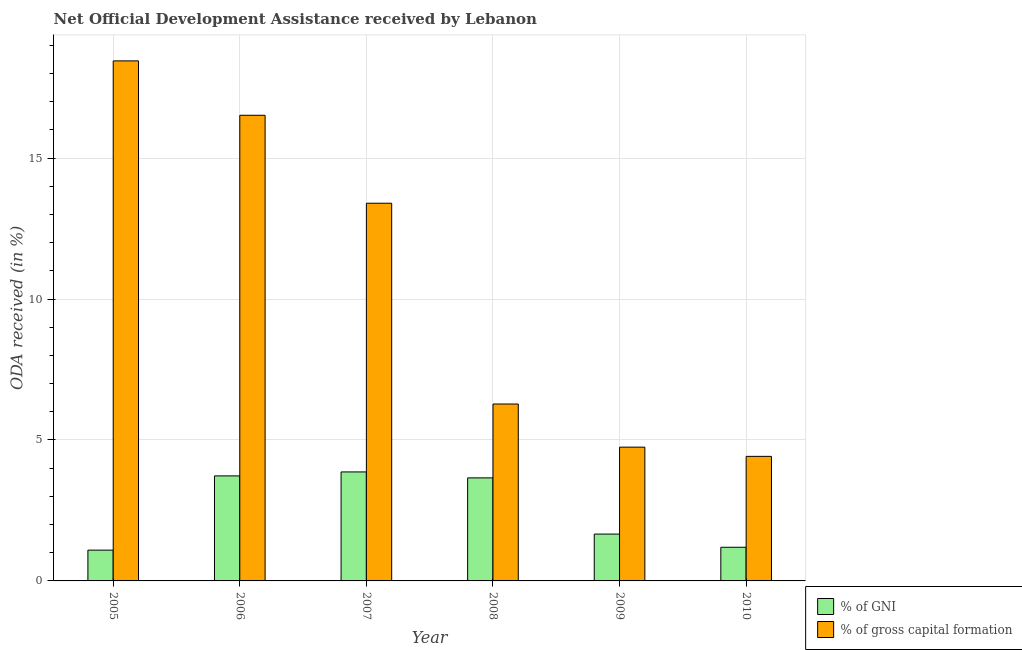How many different coloured bars are there?
Keep it short and to the point. 2. Are the number of bars on each tick of the X-axis equal?
Your answer should be compact. Yes. How many bars are there on the 1st tick from the left?
Your answer should be very brief. 2. How many bars are there on the 2nd tick from the right?
Provide a short and direct response. 2. What is the label of the 1st group of bars from the left?
Your answer should be compact. 2005. What is the oda received as percentage of gross capital formation in 2008?
Provide a short and direct response. 6.28. Across all years, what is the maximum oda received as percentage of gross capital formation?
Your answer should be very brief. 18.45. Across all years, what is the minimum oda received as percentage of gni?
Your response must be concise. 1.09. In which year was the oda received as percentage of gni maximum?
Offer a very short reply. 2007. What is the total oda received as percentage of gross capital formation in the graph?
Your answer should be very brief. 63.81. What is the difference between the oda received as percentage of gross capital formation in 2009 and that in 2010?
Your answer should be very brief. 0.33. What is the difference between the oda received as percentage of gni in 2005 and the oda received as percentage of gross capital formation in 2006?
Give a very brief answer. -2.63. What is the average oda received as percentage of gni per year?
Offer a terse response. 2.53. What is the ratio of the oda received as percentage of gross capital formation in 2006 to that in 2007?
Make the answer very short. 1.23. Is the oda received as percentage of gross capital formation in 2005 less than that in 2006?
Make the answer very short. No. What is the difference between the highest and the second highest oda received as percentage of gross capital formation?
Ensure brevity in your answer.  1.93. What is the difference between the highest and the lowest oda received as percentage of gni?
Provide a short and direct response. 2.77. In how many years, is the oda received as percentage of gross capital formation greater than the average oda received as percentage of gross capital formation taken over all years?
Your response must be concise. 3. What does the 2nd bar from the left in 2008 represents?
Provide a succinct answer. % of gross capital formation. What does the 1st bar from the right in 2007 represents?
Your answer should be very brief. % of gross capital formation. How many years are there in the graph?
Keep it short and to the point. 6. Does the graph contain any zero values?
Your answer should be very brief. No. How are the legend labels stacked?
Your answer should be compact. Vertical. What is the title of the graph?
Your answer should be very brief. Net Official Development Assistance received by Lebanon. What is the label or title of the Y-axis?
Provide a short and direct response. ODA received (in %). What is the ODA received (in %) of % of GNI in 2005?
Offer a very short reply. 1.09. What is the ODA received (in %) in % of gross capital formation in 2005?
Offer a terse response. 18.45. What is the ODA received (in %) of % of GNI in 2006?
Offer a very short reply. 3.73. What is the ODA received (in %) of % of gross capital formation in 2006?
Your response must be concise. 16.52. What is the ODA received (in %) of % of GNI in 2007?
Your answer should be very brief. 3.87. What is the ODA received (in %) in % of gross capital formation in 2007?
Keep it short and to the point. 13.4. What is the ODA received (in %) in % of GNI in 2008?
Your response must be concise. 3.66. What is the ODA received (in %) of % of gross capital formation in 2008?
Provide a short and direct response. 6.28. What is the ODA received (in %) in % of GNI in 2009?
Offer a terse response. 1.66. What is the ODA received (in %) in % of gross capital formation in 2009?
Ensure brevity in your answer.  4.75. What is the ODA received (in %) of % of GNI in 2010?
Make the answer very short. 1.19. What is the ODA received (in %) in % of gross capital formation in 2010?
Give a very brief answer. 4.42. Across all years, what is the maximum ODA received (in %) of % of GNI?
Ensure brevity in your answer.  3.87. Across all years, what is the maximum ODA received (in %) in % of gross capital formation?
Make the answer very short. 18.45. Across all years, what is the minimum ODA received (in %) in % of GNI?
Ensure brevity in your answer.  1.09. Across all years, what is the minimum ODA received (in %) of % of gross capital formation?
Provide a succinct answer. 4.42. What is the total ODA received (in %) in % of GNI in the graph?
Offer a very short reply. 15.2. What is the total ODA received (in %) of % of gross capital formation in the graph?
Keep it short and to the point. 63.81. What is the difference between the ODA received (in %) of % of GNI in 2005 and that in 2006?
Your answer should be very brief. -2.63. What is the difference between the ODA received (in %) of % of gross capital formation in 2005 and that in 2006?
Ensure brevity in your answer.  1.93. What is the difference between the ODA received (in %) in % of GNI in 2005 and that in 2007?
Your response must be concise. -2.77. What is the difference between the ODA received (in %) in % of gross capital formation in 2005 and that in 2007?
Make the answer very short. 5.05. What is the difference between the ODA received (in %) in % of GNI in 2005 and that in 2008?
Give a very brief answer. -2.56. What is the difference between the ODA received (in %) of % of gross capital formation in 2005 and that in 2008?
Provide a short and direct response. 12.17. What is the difference between the ODA received (in %) in % of GNI in 2005 and that in 2009?
Offer a terse response. -0.57. What is the difference between the ODA received (in %) in % of gross capital formation in 2005 and that in 2009?
Provide a short and direct response. 13.7. What is the difference between the ODA received (in %) of % of GNI in 2005 and that in 2010?
Make the answer very short. -0.1. What is the difference between the ODA received (in %) of % of gross capital formation in 2005 and that in 2010?
Give a very brief answer. 14.03. What is the difference between the ODA received (in %) of % of GNI in 2006 and that in 2007?
Make the answer very short. -0.14. What is the difference between the ODA received (in %) in % of gross capital formation in 2006 and that in 2007?
Offer a terse response. 3.12. What is the difference between the ODA received (in %) of % of GNI in 2006 and that in 2008?
Your answer should be compact. 0.07. What is the difference between the ODA received (in %) of % of gross capital formation in 2006 and that in 2008?
Provide a succinct answer. 10.24. What is the difference between the ODA received (in %) in % of GNI in 2006 and that in 2009?
Provide a succinct answer. 2.06. What is the difference between the ODA received (in %) in % of gross capital formation in 2006 and that in 2009?
Provide a short and direct response. 11.77. What is the difference between the ODA received (in %) in % of GNI in 2006 and that in 2010?
Provide a short and direct response. 2.53. What is the difference between the ODA received (in %) of % of gross capital formation in 2006 and that in 2010?
Your answer should be very brief. 12.1. What is the difference between the ODA received (in %) of % of GNI in 2007 and that in 2008?
Provide a short and direct response. 0.21. What is the difference between the ODA received (in %) in % of gross capital formation in 2007 and that in 2008?
Your answer should be compact. 7.12. What is the difference between the ODA received (in %) in % of GNI in 2007 and that in 2009?
Provide a short and direct response. 2.2. What is the difference between the ODA received (in %) in % of gross capital formation in 2007 and that in 2009?
Your response must be concise. 8.65. What is the difference between the ODA received (in %) of % of GNI in 2007 and that in 2010?
Make the answer very short. 2.67. What is the difference between the ODA received (in %) in % of gross capital formation in 2007 and that in 2010?
Your answer should be very brief. 8.98. What is the difference between the ODA received (in %) in % of GNI in 2008 and that in 2009?
Provide a succinct answer. 1.99. What is the difference between the ODA received (in %) in % of gross capital formation in 2008 and that in 2009?
Provide a succinct answer. 1.53. What is the difference between the ODA received (in %) of % of GNI in 2008 and that in 2010?
Make the answer very short. 2.46. What is the difference between the ODA received (in %) in % of gross capital formation in 2008 and that in 2010?
Offer a terse response. 1.86. What is the difference between the ODA received (in %) in % of GNI in 2009 and that in 2010?
Ensure brevity in your answer.  0.47. What is the difference between the ODA received (in %) of % of gross capital formation in 2009 and that in 2010?
Your response must be concise. 0.33. What is the difference between the ODA received (in %) of % of GNI in 2005 and the ODA received (in %) of % of gross capital formation in 2006?
Ensure brevity in your answer.  -15.43. What is the difference between the ODA received (in %) in % of GNI in 2005 and the ODA received (in %) in % of gross capital formation in 2007?
Your response must be concise. -12.31. What is the difference between the ODA received (in %) in % of GNI in 2005 and the ODA received (in %) in % of gross capital formation in 2008?
Make the answer very short. -5.18. What is the difference between the ODA received (in %) in % of GNI in 2005 and the ODA received (in %) in % of gross capital formation in 2009?
Make the answer very short. -3.65. What is the difference between the ODA received (in %) in % of GNI in 2005 and the ODA received (in %) in % of gross capital formation in 2010?
Make the answer very short. -3.33. What is the difference between the ODA received (in %) of % of GNI in 2006 and the ODA received (in %) of % of gross capital formation in 2007?
Provide a succinct answer. -9.67. What is the difference between the ODA received (in %) in % of GNI in 2006 and the ODA received (in %) in % of gross capital formation in 2008?
Offer a terse response. -2.55. What is the difference between the ODA received (in %) in % of GNI in 2006 and the ODA received (in %) in % of gross capital formation in 2009?
Provide a succinct answer. -1.02. What is the difference between the ODA received (in %) of % of GNI in 2006 and the ODA received (in %) of % of gross capital formation in 2010?
Ensure brevity in your answer.  -0.69. What is the difference between the ODA received (in %) of % of GNI in 2007 and the ODA received (in %) of % of gross capital formation in 2008?
Keep it short and to the point. -2.41. What is the difference between the ODA received (in %) in % of GNI in 2007 and the ODA received (in %) in % of gross capital formation in 2009?
Provide a short and direct response. -0.88. What is the difference between the ODA received (in %) of % of GNI in 2007 and the ODA received (in %) of % of gross capital formation in 2010?
Provide a short and direct response. -0.55. What is the difference between the ODA received (in %) of % of GNI in 2008 and the ODA received (in %) of % of gross capital formation in 2009?
Your answer should be compact. -1.09. What is the difference between the ODA received (in %) in % of GNI in 2008 and the ODA received (in %) in % of gross capital formation in 2010?
Your response must be concise. -0.76. What is the difference between the ODA received (in %) of % of GNI in 2009 and the ODA received (in %) of % of gross capital formation in 2010?
Your response must be concise. -2.76. What is the average ODA received (in %) of % of GNI per year?
Keep it short and to the point. 2.53. What is the average ODA received (in %) of % of gross capital formation per year?
Provide a short and direct response. 10.64. In the year 2005, what is the difference between the ODA received (in %) in % of GNI and ODA received (in %) in % of gross capital formation?
Keep it short and to the point. -17.36. In the year 2006, what is the difference between the ODA received (in %) of % of GNI and ODA received (in %) of % of gross capital formation?
Your answer should be compact. -12.79. In the year 2007, what is the difference between the ODA received (in %) in % of GNI and ODA received (in %) in % of gross capital formation?
Your response must be concise. -9.53. In the year 2008, what is the difference between the ODA received (in %) in % of GNI and ODA received (in %) in % of gross capital formation?
Your answer should be very brief. -2.62. In the year 2009, what is the difference between the ODA received (in %) in % of GNI and ODA received (in %) in % of gross capital formation?
Your answer should be very brief. -3.08. In the year 2010, what is the difference between the ODA received (in %) in % of GNI and ODA received (in %) in % of gross capital formation?
Give a very brief answer. -3.22. What is the ratio of the ODA received (in %) in % of GNI in 2005 to that in 2006?
Make the answer very short. 0.29. What is the ratio of the ODA received (in %) in % of gross capital formation in 2005 to that in 2006?
Provide a succinct answer. 1.12. What is the ratio of the ODA received (in %) of % of GNI in 2005 to that in 2007?
Keep it short and to the point. 0.28. What is the ratio of the ODA received (in %) in % of gross capital formation in 2005 to that in 2007?
Your response must be concise. 1.38. What is the ratio of the ODA received (in %) of % of GNI in 2005 to that in 2008?
Provide a short and direct response. 0.3. What is the ratio of the ODA received (in %) of % of gross capital formation in 2005 to that in 2008?
Provide a succinct answer. 2.94. What is the ratio of the ODA received (in %) of % of GNI in 2005 to that in 2009?
Ensure brevity in your answer.  0.66. What is the ratio of the ODA received (in %) in % of gross capital formation in 2005 to that in 2009?
Give a very brief answer. 3.89. What is the ratio of the ODA received (in %) of % of GNI in 2005 to that in 2010?
Your answer should be compact. 0.91. What is the ratio of the ODA received (in %) of % of gross capital formation in 2005 to that in 2010?
Offer a terse response. 4.18. What is the ratio of the ODA received (in %) in % of GNI in 2006 to that in 2007?
Offer a terse response. 0.96. What is the ratio of the ODA received (in %) of % of gross capital formation in 2006 to that in 2007?
Your response must be concise. 1.23. What is the ratio of the ODA received (in %) of % of GNI in 2006 to that in 2008?
Provide a succinct answer. 1.02. What is the ratio of the ODA received (in %) of % of gross capital formation in 2006 to that in 2008?
Make the answer very short. 2.63. What is the ratio of the ODA received (in %) in % of GNI in 2006 to that in 2009?
Your answer should be compact. 2.24. What is the ratio of the ODA received (in %) in % of gross capital formation in 2006 to that in 2009?
Your answer should be very brief. 3.48. What is the ratio of the ODA received (in %) in % of GNI in 2006 to that in 2010?
Provide a short and direct response. 3.12. What is the ratio of the ODA received (in %) of % of gross capital formation in 2006 to that in 2010?
Provide a short and direct response. 3.74. What is the ratio of the ODA received (in %) in % of GNI in 2007 to that in 2008?
Keep it short and to the point. 1.06. What is the ratio of the ODA received (in %) of % of gross capital formation in 2007 to that in 2008?
Your response must be concise. 2.13. What is the ratio of the ODA received (in %) of % of GNI in 2007 to that in 2009?
Offer a very short reply. 2.33. What is the ratio of the ODA received (in %) of % of gross capital formation in 2007 to that in 2009?
Make the answer very short. 2.82. What is the ratio of the ODA received (in %) of % of GNI in 2007 to that in 2010?
Your answer should be very brief. 3.24. What is the ratio of the ODA received (in %) of % of gross capital formation in 2007 to that in 2010?
Provide a short and direct response. 3.03. What is the ratio of the ODA received (in %) in % of GNI in 2008 to that in 2009?
Give a very brief answer. 2.2. What is the ratio of the ODA received (in %) in % of gross capital formation in 2008 to that in 2009?
Ensure brevity in your answer.  1.32. What is the ratio of the ODA received (in %) in % of GNI in 2008 to that in 2010?
Offer a very short reply. 3.06. What is the ratio of the ODA received (in %) of % of gross capital formation in 2008 to that in 2010?
Give a very brief answer. 1.42. What is the ratio of the ODA received (in %) in % of GNI in 2009 to that in 2010?
Your response must be concise. 1.39. What is the ratio of the ODA received (in %) of % of gross capital formation in 2009 to that in 2010?
Your response must be concise. 1.07. What is the difference between the highest and the second highest ODA received (in %) of % of GNI?
Your answer should be very brief. 0.14. What is the difference between the highest and the second highest ODA received (in %) of % of gross capital formation?
Offer a terse response. 1.93. What is the difference between the highest and the lowest ODA received (in %) of % of GNI?
Ensure brevity in your answer.  2.77. What is the difference between the highest and the lowest ODA received (in %) of % of gross capital formation?
Keep it short and to the point. 14.03. 